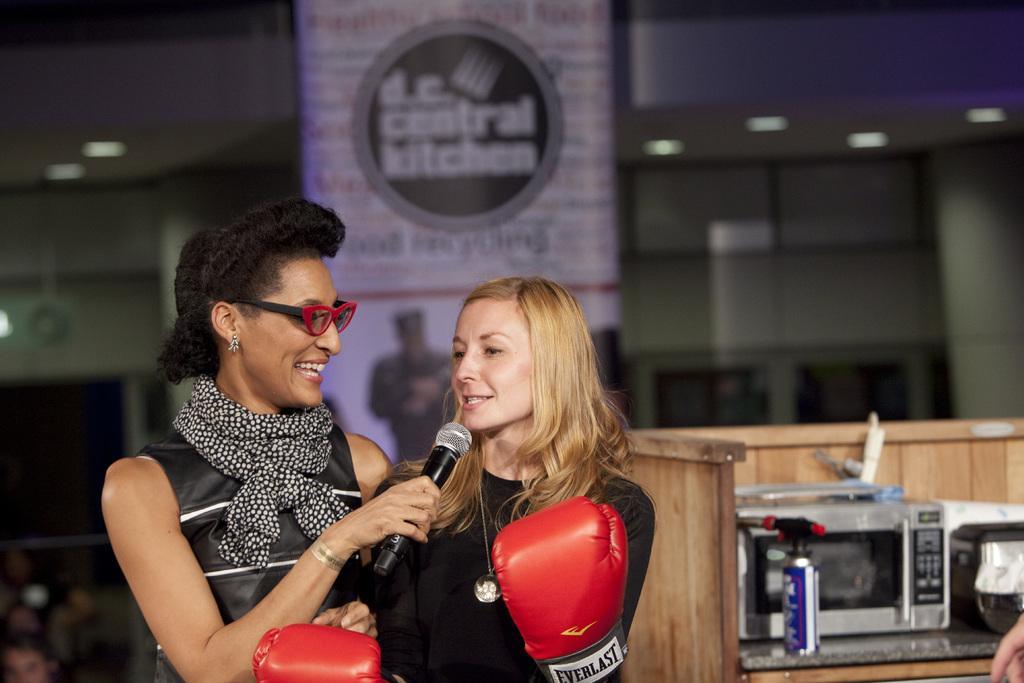Could you give a brief overview of what you see in this image? In this picture we can see two women one women wore spectacle, scarf holding mic in her hand and other woman is talking on that mic wore gloves to her hand in the background we can see table, machine, bottle, banner, light. 